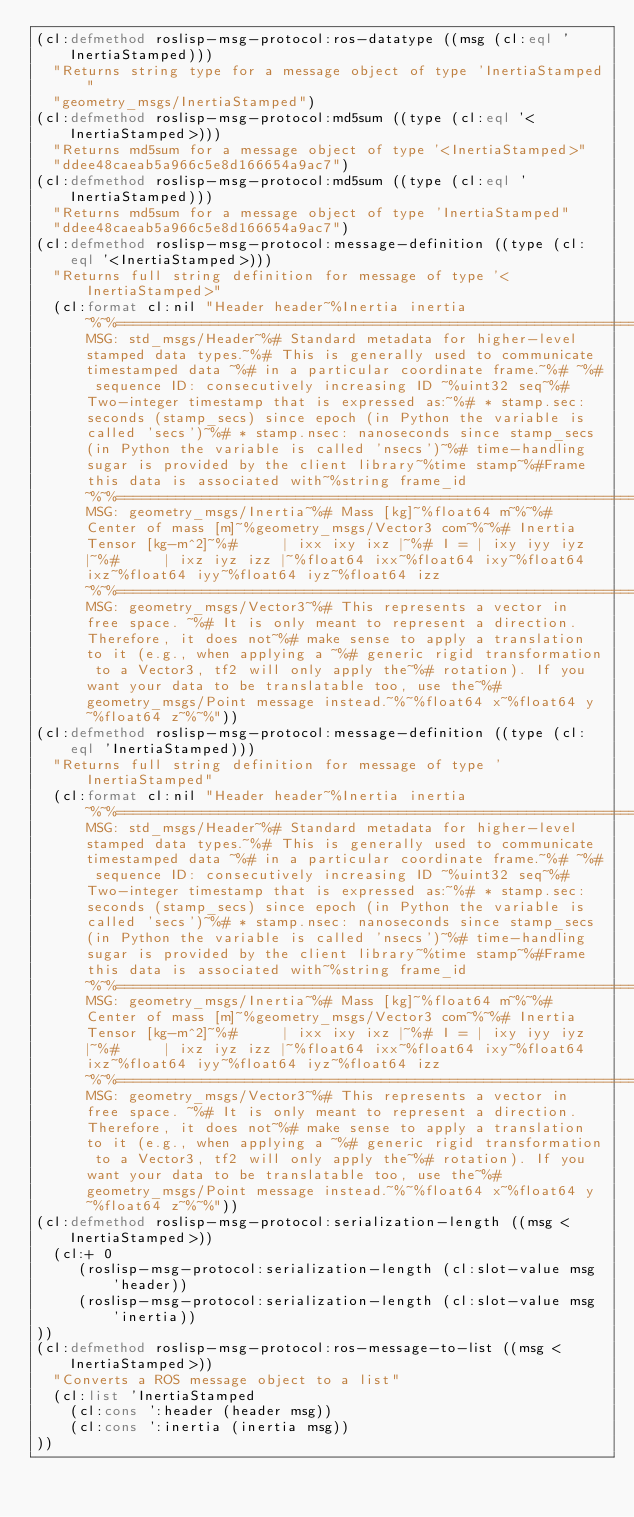Convert code to text. <code><loc_0><loc_0><loc_500><loc_500><_Lisp_>(cl:defmethod roslisp-msg-protocol:ros-datatype ((msg (cl:eql 'InertiaStamped)))
  "Returns string type for a message object of type 'InertiaStamped"
  "geometry_msgs/InertiaStamped")
(cl:defmethod roslisp-msg-protocol:md5sum ((type (cl:eql '<InertiaStamped>)))
  "Returns md5sum for a message object of type '<InertiaStamped>"
  "ddee48caeab5a966c5e8d166654a9ac7")
(cl:defmethod roslisp-msg-protocol:md5sum ((type (cl:eql 'InertiaStamped)))
  "Returns md5sum for a message object of type 'InertiaStamped"
  "ddee48caeab5a966c5e8d166654a9ac7")
(cl:defmethod roslisp-msg-protocol:message-definition ((type (cl:eql '<InertiaStamped>)))
  "Returns full string definition for message of type '<InertiaStamped>"
  (cl:format cl:nil "Header header~%Inertia inertia~%~%================================================================================~%MSG: std_msgs/Header~%# Standard metadata for higher-level stamped data types.~%# This is generally used to communicate timestamped data ~%# in a particular coordinate frame.~%# ~%# sequence ID: consecutively increasing ID ~%uint32 seq~%#Two-integer timestamp that is expressed as:~%# * stamp.sec: seconds (stamp_secs) since epoch (in Python the variable is called 'secs')~%# * stamp.nsec: nanoseconds since stamp_secs (in Python the variable is called 'nsecs')~%# time-handling sugar is provided by the client library~%time stamp~%#Frame this data is associated with~%string frame_id~%~%================================================================================~%MSG: geometry_msgs/Inertia~%# Mass [kg]~%float64 m~%~%# Center of mass [m]~%geometry_msgs/Vector3 com~%~%# Inertia Tensor [kg-m^2]~%#     | ixx ixy ixz |~%# I = | ixy iyy iyz |~%#     | ixz iyz izz |~%float64 ixx~%float64 ixy~%float64 ixz~%float64 iyy~%float64 iyz~%float64 izz~%~%================================================================================~%MSG: geometry_msgs/Vector3~%# This represents a vector in free space. ~%# It is only meant to represent a direction. Therefore, it does not~%# make sense to apply a translation to it (e.g., when applying a ~%# generic rigid transformation to a Vector3, tf2 will only apply the~%# rotation). If you want your data to be translatable too, use the~%# geometry_msgs/Point message instead.~%~%float64 x~%float64 y~%float64 z~%~%"))
(cl:defmethod roslisp-msg-protocol:message-definition ((type (cl:eql 'InertiaStamped)))
  "Returns full string definition for message of type 'InertiaStamped"
  (cl:format cl:nil "Header header~%Inertia inertia~%~%================================================================================~%MSG: std_msgs/Header~%# Standard metadata for higher-level stamped data types.~%# This is generally used to communicate timestamped data ~%# in a particular coordinate frame.~%# ~%# sequence ID: consecutively increasing ID ~%uint32 seq~%#Two-integer timestamp that is expressed as:~%# * stamp.sec: seconds (stamp_secs) since epoch (in Python the variable is called 'secs')~%# * stamp.nsec: nanoseconds since stamp_secs (in Python the variable is called 'nsecs')~%# time-handling sugar is provided by the client library~%time stamp~%#Frame this data is associated with~%string frame_id~%~%================================================================================~%MSG: geometry_msgs/Inertia~%# Mass [kg]~%float64 m~%~%# Center of mass [m]~%geometry_msgs/Vector3 com~%~%# Inertia Tensor [kg-m^2]~%#     | ixx ixy ixz |~%# I = | ixy iyy iyz |~%#     | ixz iyz izz |~%float64 ixx~%float64 ixy~%float64 ixz~%float64 iyy~%float64 iyz~%float64 izz~%~%================================================================================~%MSG: geometry_msgs/Vector3~%# This represents a vector in free space. ~%# It is only meant to represent a direction. Therefore, it does not~%# make sense to apply a translation to it (e.g., when applying a ~%# generic rigid transformation to a Vector3, tf2 will only apply the~%# rotation). If you want your data to be translatable too, use the~%# geometry_msgs/Point message instead.~%~%float64 x~%float64 y~%float64 z~%~%"))
(cl:defmethod roslisp-msg-protocol:serialization-length ((msg <InertiaStamped>))
  (cl:+ 0
     (roslisp-msg-protocol:serialization-length (cl:slot-value msg 'header))
     (roslisp-msg-protocol:serialization-length (cl:slot-value msg 'inertia))
))
(cl:defmethod roslisp-msg-protocol:ros-message-to-list ((msg <InertiaStamped>))
  "Converts a ROS message object to a list"
  (cl:list 'InertiaStamped
    (cl:cons ':header (header msg))
    (cl:cons ':inertia (inertia msg))
))
</code> 